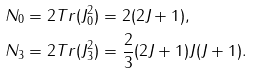Convert formula to latex. <formula><loc_0><loc_0><loc_500><loc_500>N _ { 0 } & = 2 T r ( J _ { 0 } ^ { 2 } ) = 2 ( 2 J + 1 ) , \\ N _ { 3 } & = 2 T r ( J _ { 3 } ^ { 2 } ) = \frac { 2 } { 3 } ( 2 J + 1 ) J ( J + 1 ) .</formula> 